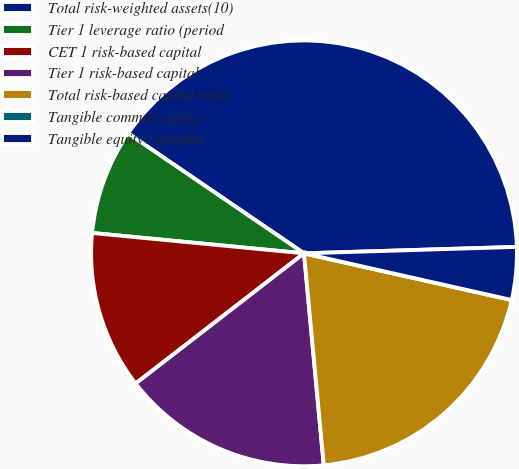Convert chart to OTSL. <chart><loc_0><loc_0><loc_500><loc_500><pie_chart><fcel>Total risk-weighted assets(10)<fcel>Tier 1 leverage ratio (period<fcel>CET 1 risk-based capital<fcel>Tier 1 risk-based capital<fcel>Total risk-based capital ratio<fcel>Tangible common equity /<fcel>Tangible equity / tangible<nl><fcel>39.99%<fcel>8.0%<fcel>12.0%<fcel>16.0%<fcel>20.0%<fcel>0.0%<fcel>4.0%<nl></chart> 